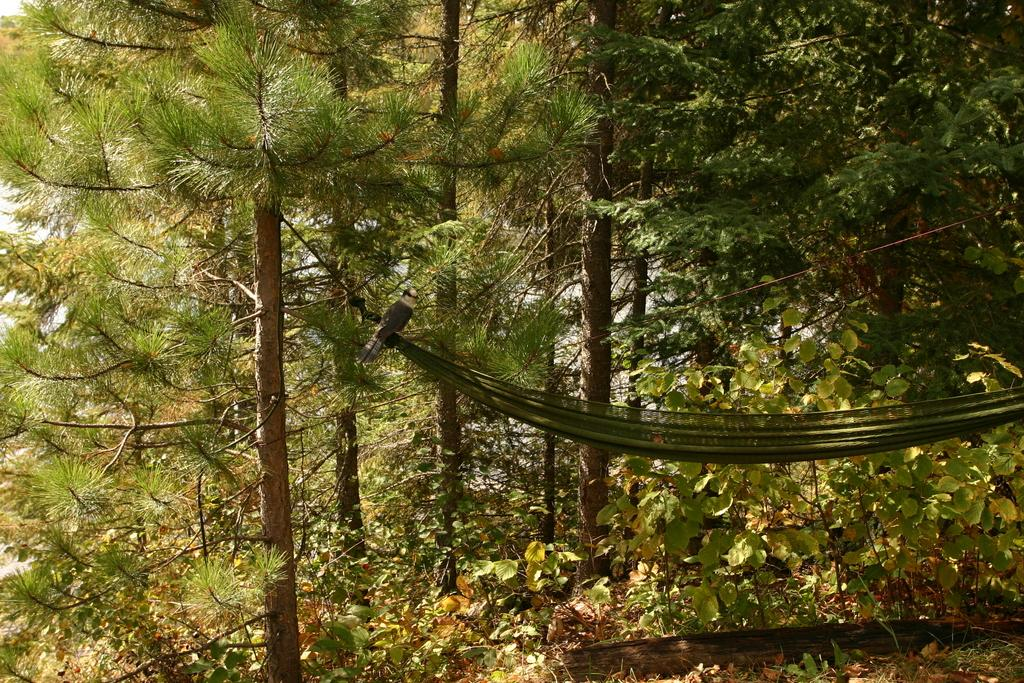What is the main object in the image? There is a cloth made as a swing in the image. What material is used to make the swing? The swing is made of cloth. What is the wooden log used for in the image? The wooden log is likely used as a support for the swing. What is holding the swing in place? Ropes are present in the image, which are likely used to hang the swing. What can be seen in the background of the image? There are trees in the background of the image. How many yaks are visible in the image? There are no yaks present in the image. What type of gun is being used to increase the height of the swing? There is no gun present in the image, and the height of the swing is maintained by the ropes. 